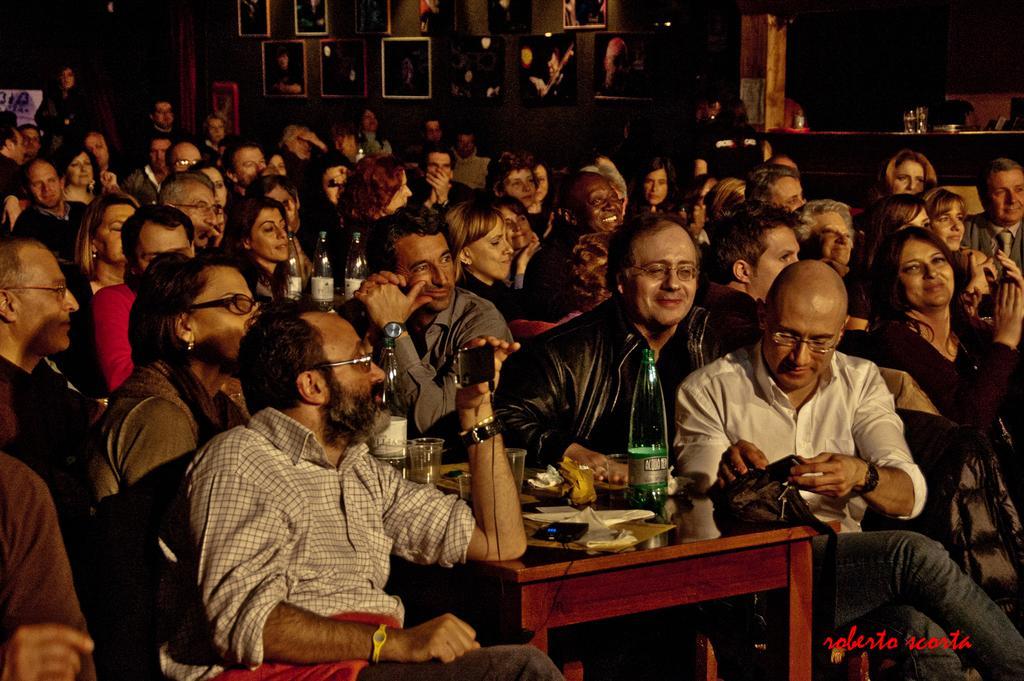Describe this image in one or two sentences. In this image i can see there are group of people who are sitting on a chair in front of a table. On the table i can see there are few glass bottles and other objects on it. 